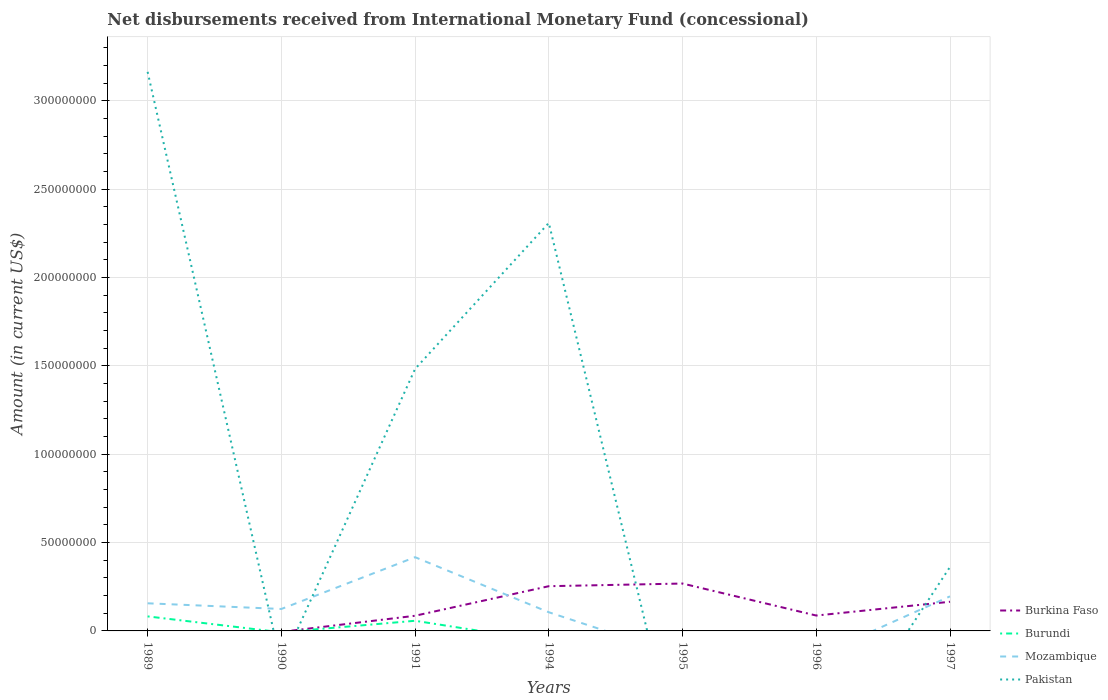How many different coloured lines are there?
Provide a short and direct response. 4. Is the number of lines equal to the number of legend labels?
Your response must be concise. No. What is the total amount of disbursements received from International Monetary Fund in Pakistan in the graph?
Offer a very short reply. -8.26e+07. What is the difference between the highest and the second highest amount of disbursements received from International Monetary Fund in Mozambique?
Offer a very short reply. 4.17e+07. What is the difference between the highest and the lowest amount of disbursements received from International Monetary Fund in Burkina Faso?
Ensure brevity in your answer.  3. Does the graph contain grids?
Offer a terse response. Yes. Where does the legend appear in the graph?
Make the answer very short. Bottom right. How many legend labels are there?
Keep it short and to the point. 4. How are the legend labels stacked?
Your answer should be compact. Vertical. What is the title of the graph?
Your answer should be very brief. Net disbursements received from International Monetary Fund (concessional). Does "Greece" appear as one of the legend labels in the graph?
Offer a terse response. No. What is the Amount (in current US$) in Burundi in 1989?
Make the answer very short. 8.22e+06. What is the Amount (in current US$) of Mozambique in 1989?
Your response must be concise. 1.56e+07. What is the Amount (in current US$) of Pakistan in 1989?
Your response must be concise. 3.16e+08. What is the Amount (in current US$) of Burkina Faso in 1990?
Ensure brevity in your answer.  0. What is the Amount (in current US$) in Mozambique in 1990?
Make the answer very short. 1.24e+07. What is the Amount (in current US$) in Pakistan in 1990?
Provide a succinct answer. 0. What is the Amount (in current US$) in Burkina Faso in 1991?
Provide a short and direct response. 8.58e+06. What is the Amount (in current US$) in Burundi in 1991?
Your answer should be very brief. 5.74e+06. What is the Amount (in current US$) in Mozambique in 1991?
Give a very brief answer. 4.17e+07. What is the Amount (in current US$) of Pakistan in 1991?
Ensure brevity in your answer.  1.48e+08. What is the Amount (in current US$) of Burkina Faso in 1994?
Provide a short and direct response. 2.53e+07. What is the Amount (in current US$) in Mozambique in 1994?
Your answer should be compact. 1.06e+07. What is the Amount (in current US$) of Pakistan in 1994?
Provide a succinct answer. 2.31e+08. What is the Amount (in current US$) of Burkina Faso in 1995?
Your answer should be very brief. 2.68e+07. What is the Amount (in current US$) in Burundi in 1995?
Offer a terse response. 0. What is the Amount (in current US$) of Mozambique in 1995?
Your answer should be compact. 0. What is the Amount (in current US$) in Pakistan in 1995?
Offer a very short reply. 0. What is the Amount (in current US$) of Burkina Faso in 1996?
Your response must be concise. 8.71e+06. What is the Amount (in current US$) in Burundi in 1996?
Provide a succinct answer. 0. What is the Amount (in current US$) of Burkina Faso in 1997?
Your response must be concise. 1.65e+07. What is the Amount (in current US$) in Burundi in 1997?
Ensure brevity in your answer.  0. What is the Amount (in current US$) of Mozambique in 1997?
Offer a terse response. 1.96e+07. What is the Amount (in current US$) of Pakistan in 1997?
Offer a very short reply. 3.62e+07. Across all years, what is the maximum Amount (in current US$) of Burkina Faso?
Your answer should be very brief. 2.68e+07. Across all years, what is the maximum Amount (in current US$) of Burundi?
Your response must be concise. 8.22e+06. Across all years, what is the maximum Amount (in current US$) of Mozambique?
Give a very brief answer. 4.17e+07. Across all years, what is the maximum Amount (in current US$) in Pakistan?
Keep it short and to the point. 3.16e+08. Across all years, what is the minimum Amount (in current US$) of Burkina Faso?
Provide a short and direct response. 0. Across all years, what is the minimum Amount (in current US$) in Burundi?
Your answer should be compact. 0. What is the total Amount (in current US$) in Burkina Faso in the graph?
Give a very brief answer. 8.59e+07. What is the total Amount (in current US$) in Burundi in the graph?
Your response must be concise. 1.40e+07. What is the total Amount (in current US$) in Mozambique in the graph?
Ensure brevity in your answer.  9.99e+07. What is the total Amount (in current US$) of Pakistan in the graph?
Your response must be concise. 7.32e+08. What is the difference between the Amount (in current US$) of Mozambique in 1989 and that in 1990?
Keep it short and to the point. 3.22e+06. What is the difference between the Amount (in current US$) in Burundi in 1989 and that in 1991?
Make the answer very short. 2.48e+06. What is the difference between the Amount (in current US$) of Mozambique in 1989 and that in 1991?
Offer a terse response. -2.61e+07. What is the difference between the Amount (in current US$) in Pakistan in 1989 and that in 1991?
Provide a succinct answer. 1.68e+08. What is the difference between the Amount (in current US$) in Mozambique in 1989 and that in 1994?
Your response must be concise. 5.07e+06. What is the difference between the Amount (in current US$) in Pakistan in 1989 and that in 1994?
Your answer should be very brief. 8.55e+07. What is the difference between the Amount (in current US$) of Mozambique in 1989 and that in 1997?
Give a very brief answer. -3.93e+06. What is the difference between the Amount (in current US$) in Pakistan in 1989 and that in 1997?
Provide a succinct answer. 2.80e+08. What is the difference between the Amount (in current US$) in Mozambique in 1990 and that in 1991?
Offer a terse response. -2.93e+07. What is the difference between the Amount (in current US$) in Mozambique in 1990 and that in 1994?
Provide a short and direct response. 1.85e+06. What is the difference between the Amount (in current US$) in Mozambique in 1990 and that in 1997?
Your answer should be compact. -7.15e+06. What is the difference between the Amount (in current US$) of Burkina Faso in 1991 and that in 1994?
Offer a terse response. -1.67e+07. What is the difference between the Amount (in current US$) in Mozambique in 1991 and that in 1994?
Provide a succinct answer. 3.12e+07. What is the difference between the Amount (in current US$) in Pakistan in 1991 and that in 1994?
Keep it short and to the point. -8.26e+07. What is the difference between the Amount (in current US$) of Burkina Faso in 1991 and that in 1995?
Offer a terse response. -1.82e+07. What is the difference between the Amount (in current US$) in Burkina Faso in 1991 and that in 1996?
Ensure brevity in your answer.  -1.25e+05. What is the difference between the Amount (in current US$) in Burkina Faso in 1991 and that in 1997?
Keep it short and to the point. -7.93e+06. What is the difference between the Amount (in current US$) of Mozambique in 1991 and that in 1997?
Provide a short and direct response. 2.22e+07. What is the difference between the Amount (in current US$) in Pakistan in 1991 and that in 1997?
Ensure brevity in your answer.  1.12e+08. What is the difference between the Amount (in current US$) in Burkina Faso in 1994 and that in 1995?
Give a very brief answer. -1.51e+06. What is the difference between the Amount (in current US$) of Burkina Faso in 1994 and that in 1996?
Your response must be concise. 1.66e+07. What is the difference between the Amount (in current US$) of Burkina Faso in 1994 and that in 1997?
Provide a short and direct response. 8.81e+06. What is the difference between the Amount (in current US$) in Mozambique in 1994 and that in 1997?
Your response must be concise. -9.00e+06. What is the difference between the Amount (in current US$) in Pakistan in 1994 and that in 1997?
Provide a short and direct response. 1.95e+08. What is the difference between the Amount (in current US$) in Burkina Faso in 1995 and that in 1996?
Offer a very short reply. 1.81e+07. What is the difference between the Amount (in current US$) in Burkina Faso in 1995 and that in 1997?
Your response must be concise. 1.03e+07. What is the difference between the Amount (in current US$) of Burkina Faso in 1996 and that in 1997?
Keep it short and to the point. -7.80e+06. What is the difference between the Amount (in current US$) of Burundi in 1989 and the Amount (in current US$) of Mozambique in 1990?
Your answer should be compact. -4.20e+06. What is the difference between the Amount (in current US$) of Burundi in 1989 and the Amount (in current US$) of Mozambique in 1991?
Your response must be concise. -3.35e+07. What is the difference between the Amount (in current US$) of Burundi in 1989 and the Amount (in current US$) of Pakistan in 1991?
Offer a terse response. -1.40e+08. What is the difference between the Amount (in current US$) of Mozambique in 1989 and the Amount (in current US$) of Pakistan in 1991?
Provide a short and direct response. -1.33e+08. What is the difference between the Amount (in current US$) in Burundi in 1989 and the Amount (in current US$) in Mozambique in 1994?
Ensure brevity in your answer.  -2.34e+06. What is the difference between the Amount (in current US$) of Burundi in 1989 and the Amount (in current US$) of Pakistan in 1994?
Your answer should be compact. -2.23e+08. What is the difference between the Amount (in current US$) of Mozambique in 1989 and the Amount (in current US$) of Pakistan in 1994?
Keep it short and to the point. -2.15e+08. What is the difference between the Amount (in current US$) in Burundi in 1989 and the Amount (in current US$) in Mozambique in 1997?
Keep it short and to the point. -1.13e+07. What is the difference between the Amount (in current US$) of Burundi in 1989 and the Amount (in current US$) of Pakistan in 1997?
Provide a short and direct response. -2.80e+07. What is the difference between the Amount (in current US$) in Mozambique in 1989 and the Amount (in current US$) in Pakistan in 1997?
Ensure brevity in your answer.  -2.06e+07. What is the difference between the Amount (in current US$) of Mozambique in 1990 and the Amount (in current US$) of Pakistan in 1991?
Ensure brevity in your answer.  -1.36e+08. What is the difference between the Amount (in current US$) in Mozambique in 1990 and the Amount (in current US$) in Pakistan in 1994?
Give a very brief answer. -2.19e+08. What is the difference between the Amount (in current US$) in Mozambique in 1990 and the Amount (in current US$) in Pakistan in 1997?
Keep it short and to the point. -2.38e+07. What is the difference between the Amount (in current US$) of Burkina Faso in 1991 and the Amount (in current US$) of Mozambique in 1994?
Ensure brevity in your answer.  -1.99e+06. What is the difference between the Amount (in current US$) in Burkina Faso in 1991 and the Amount (in current US$) in Pakistan in 1994?
Offer a terse response. -2.22e+08. What is the difference between the Amount (in current US$) of Burundi in 1991 and the Amount (in current US$) of Mozambique in 1994?
Give a very brief answer. -4.82e+06. What is the difference between the Amount (in current US$) of Burundi in 1991 and the Amount (in current US$) of Pakistan in 1994?
Provide a succinct answer. -2.25e+08. What is the difference between the Amount (in current US$) of Mozambique in 1991 and the Amount (in current US$) of Pakistan in 1994?
Make the answer very short. -1.89e+08. What is the difference between the Amount (in current US$) of Burkina Faso in 1991 and the Amount (in current US$) of Mozambique in 1997?
Provide a succinct answer. -1.10e+07. What is the difference between the Amount (in current US$) in Burkina Faso in 1991 and the Amount (in current US$) in Pakistan in 1997?
Give a very brief answer. -2.76e+07. What is the difference between the Amount (in current US$) in Burundi in 1991 and the Amount (in current US$) in Mozambique in 1997?
Keep it short and to the point. -1.38e+07. What is the difference between the Amount (in current US$) of Burundi in 1991 and the Amount (in current US$) of Pakistan in 1997?
Provide a succinct answer. -3.05e+07. What is the difference between the Amount (in current US$) of Mozambique in 1991 and the Amount (in current US$) of Pakistan in 1997?
Your answer should be very brief. 5.52e+06. What is the difference between the Amount (in current US$) of Burkina Faso in 1994 and the Amount (in current US$) of Mozambique in 1997?
Your response must be concise. 5.75e+06. What is the difference between the Amount (in current US$) of Burkina Faso in 1994 and the Amount (in current US$) of Pakistan in 1997?
Offer a very short reply. -1.09e+07. What is the difference between the Amount (in current US$) of Mozambique in 1994 and the Amount (in current US$) of Pakistan in 1997?
Provide a short and direct response. -2.57e+07. What is the difference between the Amount (in current US$) of Burkina Faso in 1995 and the Amount (in current US$) of Mozambique in 1997?
Offer a very short reply. 7.26e+06. What is the difference between the Amount (in current US$) of Burkina Faso in 1995 and the Amount (in current US$) of Pakistan in 1997?
Offer a terse response. -9.40e+06. What is the difference between the Amount (in current US$) in Burkina Faso in 1996 and the Amount (in current US$) in Mozambique in 1997?
Provide a succinct answer. -1.09e+07. What is the difference between the Amount (in current US$) of Burkina Faso in 1996 and the Amount (in current US$) of Pakistan in 1997?
Provide a succinct answer. -2.75e+07. What is the average Amount (in current US$) in Burkina Faso per year?
Keep it short and to the point. 1.23e+07. What is the average Amount (in current US$) in Burundi per year?
Provide a short and direct response. 2.00e+06. What is the average Amount (in current US$) of Mozambique per year?
Offer a very short reply. 1.43e+07. What is the average Amount (in current US$) in Pakistan per year?
Offer a very short reply. 1.05e+08. In the year 1989, what is the difference between the Amount (in current US$) of Burundi and Amount (in current US$) of Mozambique?
Keep it short and to the point. -7.42e+06. In the year 1989, what is the difference between the Amount (in current US$) of Burundi and Amount (in current US$) of Pakistan?
Make the answer very short. -3.08e+08. In the year 1989, what is the difference between the Amount (in current US$) in Mozambique and Amount (in current US$) in Pakistan?
Give a very brief answer. -3.01e+08. In the year 1991, what is the difference between the Amount (in current US$) in Burkina Faso and Amount (in current US$) in Burundi?
Your response must be concise. 2.84e+06. In the year 1991, what is the difference between the Amount (in current US$) of Burkina Faso and Amount (in current US$) of Mozambique?
Keep it short and to the point. -3.32e+07. In the year 1991, what is the difference between the Amount (in current US$) in Burkina Faso and Amount (in current US$) in Pakistan?
Your response must be concise. -1.40e+08. In the year 1991, what is the difference between the Amount (in current US$) of Burundi and Amount (in current US$) of Mozambique?
Ensure brevity in your answer.  -3.60e+07. In the year 1991, what is the difference between the Amount (in current US$) in Burundi and Amount (in current US$) in Pakistan?
Your response must be concise. -1.43e+08. In the year 1991, what is the difference between the Amount (in current US$) of Mozambique and Amount (in current US$) of Pakistan?
Your answer should be compact. -1.07e+08. In the year 1994, what is the difference between the Amount (in current US$) in Burkina Faso and Amount (in current US$) in Mozambique?
Keep it short and to the point. 1.48e+07. In the year 1994, what is the difference between the Amount (in current US$) in Burkina Faso and Amount (in current US$) in Pakistan?
Make the answer very short. -2.06e+08. In the year 1994, what is the difference between the Amount (in current US$) in Mozambique and Amount (in current US$) in Pakistan?
Ensure brevity in your answer.  -2.20e+08. In the year 1997, what is the difference between the Amount (in current US$) in Burkina Faso and Amount (in current US$) in Mozambique?
Keep it short and to the point. -3.06e+06. In the year 1997, what is the difference between the Amount (in current US$) in Burkina Faso and Amount (in current US$) in Pakistan?
Your answer should be compact. -1.97e+07. In the year 1997, what is the difference between the Amount (in current US$) in Mozambique and Amount (in current US$) in Pakistan?
Your answer should be compact. -1.67e+07. What is the ratio of the Amount (in current US$) of Mozambique in 1989 to that in 1990?
Make the answer very short. 1.26. What is the ratio of the Amount (in current US$) in Burundi in 1989 to that in 1991?
Keep it short and to the point. 1.43. What is the ratio of the Amount (in current US$) in Mozambique in 1989 to that in 1991?
Provide a succinct answer. 0.37. What is the ratio of the Amount (in current US$) in Pakistan in 1989 to that in 1991?
Provide a short and direct response. 2.13. What is the ratio of the Amount (in current US$) in Mozambique in 1989 to that in 1994?
Provide a short and direct response. 1.48. What is the ratio of the Amount (in current US$) of Pakistan in 1989 to that in 1994?
Provide a succinct answer. 1.37. What is the ratio of the Amount (in current US$) in Mozambique in 1989 to that in 1997?
Your answer should be very brief. 0.8. What is the ratio of the Amount (in current US$) of Pakistan in 1989 to that in 1997?
Your answer should be very brief. 8.74. What is the ratio of the Amount (in current US$) in Mozambique in 1990 to that in 1991?
Offer a terse response. 0.3. What is the ratio of the Amount (in current US$) of Mozambique in 1990 to that in 1994?
Give a very brief answer. 1.18. What is the ratio of the Amount (in current US$) in Mozambique in 1990 to that in 1997?
Offer a terse response. 0.63. What is the ratio of the Amount (in current US$) in Burkina Faso in 1991 to that in 1994?
Provide a short and direct response. 0.34. What is the ratio of the Amount (in current US$) in Mozambique in 1991 to that in 1994?
Offer a very short reply. 3.95. What is the ratio of the Amount (in current US$) of Pakistan in 1991 to that in 1994?
Make the answer very short. 0.64. What is the ratio of the Amount (in current US$) of Burkina Faso in 1991 to that in 1995?
Your answer should be very brief. 0.32. What is the ratio of the Amount (in current US$) in Burkina Faso in 1991 to that in 1996?
Make the answer very short. 0.99. What is the ratio of the Amount (in current US$) of Burkina Faso in 1991 to that in 1997?
Your response must be concise. 0.52. What is the ratio of the Amount (in current US$) in Mozambique in 1991 to that in 1997?
Keep it short and to the point. 2.13. What is the ratio of the Amount (in current US$) in Pakistan in 1991 to that in 1997?
Your answer should be compact. 4.09. What is the ratio of the Amount (in current US$) in Burkina Faso in 1994 to that in 1995?
Your answer should be compact. 0.94. What is the ratio of the Amount (in current US$) in Burkina Faso in 1994 to that in 1996?
Your response must be concise. 2.91. What is the ratio of the Amount (in current US$) of Burkina Faso in 1994 to that in 1997?
Offer a very short reply. 1.53. What is the ratio of the Amount (in current US$) in Mozambique in 1994 to that in 1997?
Your response must be concise. 0.54. What is the ratio of the Amount (in current US$) of Pakistan in 1994 to that in 1997?
Your answer should be very brief. 6.38. What is the ratio of the Amount (in current US$) in Burkina Faso in 1995 to that in 1996?
Your answer should be very brief. 3.08. What is the ratio of the Amount (in current US$) of Burkina Faso in 1995 to that in 1997?
Make the answer very short. 1.62. What is the ratio of the Amount (in current US$) in Burkina Faso in 1996 to that in 1997?
Ensure brevity in your answer.  0.53. What is the difference between the highest and the second highest Amount (in current US$) of Burkina Faso?
Keep it short and to the point. 1.51e+06. What is the difference between the highest and the second highest Amount (in current US$) in Mozambique?
Your answer should be very brief. 2.22e+07. What is the difference between the highest and the second highest Amount (in current US$) in Pakistan?
Your answer should be compact. 8.55e+07. What is the difference between the highest and the lowest Amount (in current US$) in Burkina Faso?
Your answer should be very brief. 2.68e+07. What is the difference between the highest and the lowest Amount (in current US$) of Burundi?
Offer a very short reply. 8.22e+06. What is the difference between the highest and the lowest Amount (in current US$) in Mozambique?
Provide a short and direct response. 4.17e+07. What is the difference between the highest and the lowest Amount (in current US$) of Pakistan?
Offer a very short reply. 3.16e+08. 